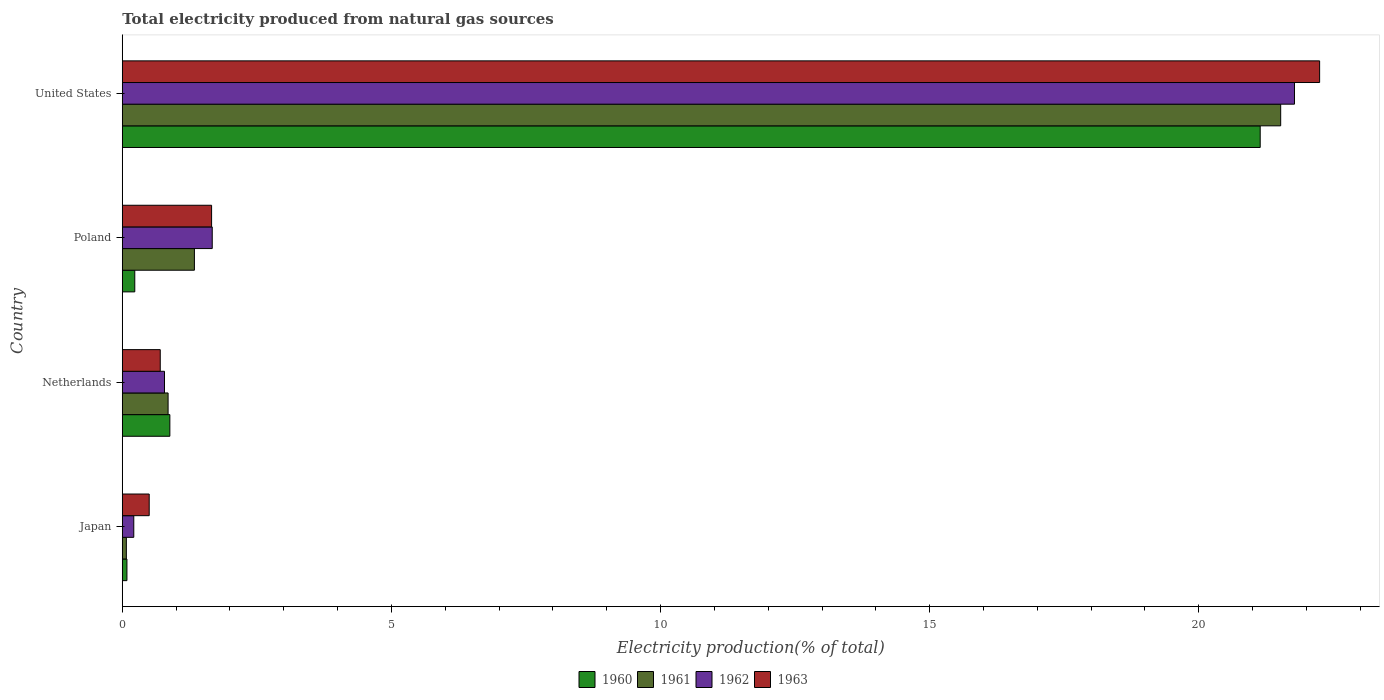How many groups of bars are there?
Offer a very short reply. 4. Are the number of bars on each tick of the Y-axis equal?
Offer a very short reply. Yes. How many bars are there on the 1st tick from the top?
Provide a short and direct response. 4. What is the total electricity produced in 1961 in Netherlands?
Provide a short and direct response. 0.85. Across all countries, what is the maximum total electricity produced in 1960?
Offer a terse response. 21.14. Across all countries, what is the minimum total electricity produced in 1960?
Offer a very short reply. 0.09. In which country was the total electricity produced in 1962 minimum?
Ensure brevity in your answer.  Japan. What is the total total electricity produced in 1962 in the graph?
Ensure brevity in your answer.  24.45. What is the difference between the total electricity produced in 1961 in Poland and that in United States?
Offer a terse response. -20.18. What is the difference between the total electricity produced in 1962 in Japan and the total electricity produced in 1960 in Poland?
Your response must be concise. -0.02. What is the average total electricity produced in 1962 per country?
Give a very brief answer. 6.11. What is the difference between the total electricity produced in 1961 and total electricity produced in 1962 in Poland?
Your answer should be very brief. -0.33. In how many countries, is the total electricity produced in 1963 greater than 9 %?
Give a very brief answer. 1. What is the ratio of the total electricity produced in 1961 in Poland to that in United States?
Offer a terse response. 0.06. Is the total electricity produced in 1960 in Netherlands less than that in Poland?
Keep it short and to the point. No. What is the difference between the highest and the second highest total electricity produced in 1962?
Make the answer very short. 20.11. What is the difference between the highest and the lowest total electricity produced in 1962?
Your answer should be very brief. 21.56. In how many countries, is the total electricity produced in 1962 greater than the average total electricity produced in 1962 taken over all countries?
Your answer should be very brief. 1. Is it the case that in every country, the sum of the total electricity produced in 1962 and total electricity produced in 1963 is greater than the sum of total electricity produced in 1960 and total electricity produced in 1961?
Provide a short and direct response. No. What does the 3rd bar from the top in Netherlands represents?
Your response must be concise. 1961. What is the difference between two consecutive major ticks on the X-axis?
Ensure brevity in your answer.  5. Are the values on the major ticks of X-axis written in scientific E-notation?
Provide a short and direct response. No. Where does the legend appear in the graph?
Give a very brief answer. Bottom center. What is the title of the graph?
Your answer should be compact. Total electricity produced from natural gas sources. What is the label or title of the Y-axis?
Your answer should be compact. Country. What is the Electricity production(% of total) in 1960 in Japan?
Ensure brevity in your answer.  0.09. What is the Electricity production(% of total) in 1961 in Japan?
Ensure brevity in your answer.  0.08. What is the Electricity production(% of total) in 1962 in Japan?
Your answer should be compact. 0.21. What is the Electricity production(% of total) of 1963 in Japan?
Give a very brief answer. 0.5. What is the Electricity production(% of total) of 1960 in Netherlands?
Ensure brevity in your answer.  0.88. What is the Electricity production(% of total) of 1961 in Netherlands?
Make the answer very short. 0.85. What is the Electricity production(% of total) of 1962 in Netherlands?
Ensure brevity in your answer.  0.78. What is the Electricity production(% of total) in 1963 in Netherlands?
Keep it short and to the point. 0.71. What is the Electricity production(% of total) of 1960 in Poland?
Offer a very short reply. 0.23. What is the Electricity production(% of total) in 1961 in Poland?
Give a very brief answer. 1.34. What is the Electricity production(% of total) of 1962 in Poland?
Offer a very short reply. 1.67. What is the Electricity production(% of total) in 1963 in Poland?
Provide a succinct answer. 1.66. What is the Electricity production(% of total) in 1960 in United States?
Keep it short and to the point. 21.14. What is the Electricity production(% of total) of 1961 in United States?
Offer a terse response. 21.52. What is the Electricity production(% of total) in 1962 in United States?
Ensure brevity in your answer.  21.78. What is the Electricity production(% of total) of 1963 in United States?
Offer a terse response. 22.24. Across all countries, what is the maximum Electricity production(% of total) in 1960?
Offer a terse response. 21.14. Across all countries, what is the maximum Electricity production(% of total) in 1961?
Your response must be concise. 21.52. Across all countries, what is the maximum Electricity production(% of total) of 1962?
Ensure brevity in your answer.  21.78. Across all countries, what is the maximum Electricity production(% of total) of 1963?
Provide a short and direct response. 22.24. Across all countries, what is the minimum Electricity production(% of total) in 1960?
Offer a very short reply. 0.09. Across all countries, what is the minimum Electricity production(% of total) of 1961?
Provide a short and direct response. 0.08. Across all countries, what is the minimum Electricity production(% of total) in 1962?
Your answer should be very brief. 0.21. Across all countries, what is the minimum Electricity production(% of total) in 1963?
Provide a succinct answer. 0.5. What is the total Electricity production(% of total) in 1960 in the graph?
Provide a succinct answer. 22.34. What is the total Electricity production(% of total) of 1961 in the graph?
Keep it short and to the point. 23.79. What is the total Electricity production(% of total) in 1962 in the graph?
Your answer should be very brief. 24.45. What is the total Electricity production(% of total) in 1963 in the graph?
Offer a terse response. 25.11. What is the difference between the Electricity production(% of total) of 1960 in Japan and that in Netherlands?
Provide a succinct answer. -0.8. What is the difference between the Electricity production(% of total) of 1961 in Japan and that in Netherlands?
Offer a very short reply. -0.78. What is the difference between the Electricity production(% of total) of 1962 in Japan and that in Netherlands?
Provide a short and direct response. -0.57. What is the difference between the Electricity production(% of total) in 1963 in Japan and that in Netherlands?
Offer a terse response. -0.21. What is the difference between the Electricity production(% of total) of 1960 in Japan and that in Poland?
Your answer should be compact. -0.15. What is the difference between the Electricity production(% of total) of 1961 in Japan and that in Poland?
Provide a succinct answer. -1.26. What is the difference between the Electricity production(% of total) in 1962 in Japan and that in Poland?
Your response must be concise. -1.46. What is the difference between the Electricity production(% of total) in 1963 in Japan and that in Poland?
Make the answer very short. -1.16. What is the difference between the Electricity production(% of total) of 1960 in Japan and that in United States?
Your response must be concise. -21.05. What is the difference between the Electricity production(% of total) in 1961 in Japan and that in United States?
Offer a terse response. -21.45. What is the difference between the Electricity production(% of total) in 1962 in Japan and that in United States?
Ensure brevity in your answer.  -21.56. What is the difference between the Electricity production(% of total) of 1963 in Japan and that in United States?
Your response must be concise. -21.74. What is the difference between the Electricity production(% of total) in 1960 in Netherlands and that in Poland?
Keep it short and to the point. 0.65. What is the difference between the Electricity production(% of total) in 1961 in Netherlands and that in Poland?
Give a very brief answer. -0.49. What is the difference between the Electricity production(% of total) of 1962 in Netherlands and that in Poland?
Offer a very short reply. -0.89. What is the difference between the Electricity production(% of total) of 1963 in Netherlands and that in Poland?
Offer a terse response. -0.95. What is the difference between the Electricity production(% of total) in 1960 in Netherlands and that in United States?
Your response must be concise. -20.26. What is the difference between the Electricity production(% of total) in 1961 in Netherlands and that in United States?
Your answer should be compact. -20.67. What is the difference between the Electricity production(% of total) of 1962 in Netherlands and that in United States?
Ensure brevity in your answer.  -20.99. What is the difference between the Electricity production(% of total) in 1963 in Netherlands and that in United States?
Provide a succinct answer. -21.54. What is the difference between the Electricity production(% of total) in 1960 in Poland and that in United States?
Offer a terse response. -20.91. What is the difference between the Electricity production(% of total) in 1961 in Poland and that in United States?
Provide a short and direct response. -20.18. What is the difference between the Electricity production(% of total) in 1962 in Poland and that in United States?
Your answer should be compact. -20.11. What is the difference between the Electricity production(% of total) of 1963 in Poland and that in United States?
Make the answer very short. -20.59. What is the difference between the Electricity production(% of total) of 1960 in Japan and the Electricity production(% of total) of 1961 in Netherlands?
Keep it short and to the point. -0.76. What is the difference between the Electricity production(% of total) of 1960 in Japan and the Electricity production(% of total) of 1962 in Netherlands?
Your answer should be very brief. -0.7. What is the difference between the Electricity production(% of total) of 1960 in Japan and the Electricity production(% of total) of 1963 in Netherlands?
Provide a short and direct response. -0.62. What is the difference between the Electricity production(% of total) of 1961 in Japan and the Electricity production(% of total) of 1962 in Netherlands?
Provide a succinct answer. -0.71. What is the difference between the Electricity production(% of total) in 1961 in Japan and the Electricity production(% of total) in 1963 in Netherlands?
Offer a terse response. -0.63. What is the difference between the Electricity production(% of total) in 1962 in Japan and the Electricity production(% of total) in 1963 in Netherlands?
Give a very brief answer. -0.49. What is the difference between the Electricity production(% of total) of 1960 in Japan and the Electricity production(% of total) of 1961 in Poland?
Provide a short and direct response. -1.25. What is the difference between the Electricity production(% of total) of 1960 in Japan and the Electricity production(% of total) of 1962 in Poland?
Ensure brevity in your answer.  -1.58. What is the difference between the Electricity production(% of total) of 1960 in Japan and the Electricity production(% of total) of 1963 in Poland?
Make the answer very short. -1.57. What is the difference between the Electricity production(% of total) of 1961 in Japan and the Electricity production(% of total) of 1962 in Poland?
Make the answer very short. -1.6. What is the difference between the Electricity production(% of total) of 1961 in Japan and the Electricity production(% of total) of 1963 in Poland?
Give a very brief answer. -1.58. What is the difference between the Electricity production(% of total) in 1962 in Japan and the Electricity production(% of total) in 1963 in Poland?
Give a very brief answer. -1.45. What is the difference between the Electricity production(% of total) in 1960 in Japan and the Electricity production(% of total) in 1961 in United States?
Make the answer very short. -21.43. What is the difference between the Electricity production(% of total) in 1960 in Japan and the Electricity production(% of total) in 1962 in United States?
Give a very brief answer. -21.69. What is the difference between the Electricity production(% of total) of 1960 in Japan and the Electricity production(% of total) of 1963 in United States?
Make the answer very short. -22.16. What is the difference between the Electricity production(% of total) of 1961 in Japan and the Electricity production(% of total) of 1962 in United States?
Provide a short and direct response. -21.7. What is the difference between the Electricity production(% of total) in 1961 in Japan and the Electricity production(% of total) in 1963 in United States?
Offer a very short reply. -22.17. What is the difference between the Electricity production(% of total) in 1962 in Japan and the Electricity production(% of total) in 1963 in United States?
Give a very brief answer. -22.03. What is the difference between the Electricity production(% of total) of 1960 in Netherlands and the Electricity production(% of total) of 1961 in Poland?
Provide a succinct answer. -0.46. What is the difference between the Electricity production(% of total) in 1960 in Netherlands and the Electricity production(% of total) in 1962 in Poland?
Provide a succinct answer. -0.79. What is the difference between the Electricity production(% of total) in 1960 in Netherlands and the Electricity production(% of total) in 1963 in Poland?
Provide a short and direct response. -0.78. What is the difference between the Electricity production(% of total) of 1961 in Netherlands and the Electricity production(% of total) of 1962 in Poland?
Make the answer very short. -0.82. What is the difference between the Electricity production(% of total) of 1961 in Netherlands and the Electricity production(% of total) of 1963 in Poland?
Your response must be concise. -0.81. What is the difference between the Electricity production(% of total) in 1962 in Netherlands and the Electricity production(% of total) in 1963 in Poland?
Provide a short and direct response. -0.88. What is the difference between the Electricity production(% of total) of 1960 in Netherlands and the Electricity production(% of total) of 1961 in United States?
Provide a succinct answer. -20.64. What is the difference between the Electricity production(% of total) in 1960 in Netherlands and the Electricity production(% of total) in 1962 in United States?
Keep it short and to the point. -20.89. What is the difference between the Electricity production(% of total) of 1960 in Netherlands and the Electricity production(% of total) of 1963 in United States?
Provide a short and direct response. -21.36. What is the difference between the Electricity production(% of total) in 1961 in Netherlands and the Electricity production(% of total) in 1962 in United States?
Your answer should be very brief. -20.93. What is the difference between the Electricity production(% of total) of 1961 in Netherlands and the Electricity production(% of total) of 1963 in United States?
Provide a succinct answer. -21.39. What is the difference between the Electricity production(% of total) of 1962 in Netherlands and the Electricity production(% of total) of 1963 in United States?
Keep it short and to the point. -21.46. What is the difference between the Electricity production(% of total) of 1960 in Poland and the Electricity production(% of total) of 1961 in United States?
Your answer should be very brief. -21.29. What is the difference between the Electricity production(% of total) in 1960 in Poland and the Electricity production(% of total) in 1962 in United States?
Offer a very short reply. -21.55. What is the difference between the Electricity production(% of total) in 1960 in Poland and the Electricity production(% of total) in 1963 in United States?
Your answer should be very brief. -22.01. What is the difference between the Electricity production(% of total) of 1961 in Poland and the Electricity production(% of total) of 1962 in United States?
Offer a very short reply. -20.44. What is the difference between the Electricity production(% of total) in 1961 in Poland and the Electricity production(% of total) in 1963 in United States?
Provide a succinct answer. -20.91. What is the difference between the Electricity production(% of total) of 1962 in Poland and the Electricity production(% of total) of 1963 in United States?
Offer a terse response. -20.57. What is the average Electricity production(% of total) in 1960 per country?
Your response must be concise. 5.59. What is the average Electricity production(% of total) in 1961 per country?
Your response must be concise. 5.95. What is the average Electricity production(% of total) of 1962 per country?
Provide a short and direct response. 6.11. What is the average Electricity production(% of total) in 1963 per country?
Ensure brevity in your answer.  6.28. What is the difference between the Electricity production(% of total) in 1960 and Electricity production(% of total) in 1961 in Japan?
Ensure brevity in your answer.  0.01. What is the difference between the Electricity production(% of total) of 1960 and Electricity production(% of total) of 1962 in Japan?
Your response must be concise. -0.13. What is the difference between the Electricity production(% of total) in 1960 and Electricity production(% of total) in 1963 in Japan?
Make the answer very short. -0.41. What is the difference between the Electricity production(% of total) of 1961 and Electricity production(% of total) of 1962 in Japan?
Keep it short and to the point. -0.14. What is the difference between the Electricity production(% of total) in 1961 and Electricity production(% of total) in 1963 in Japan?
Give a very brief answer. -0.42. What is the difference between the Electricity production(% of total) of 1962 and Electricity production(% of total) of 1963 in Japan?
Your response must be concise. -0.29. What is the difference between the Electricity production(% of total) of 1960 and Electricity production(% of total) of 1961 in Netherlands?
Give a very brief answer. 0.03. What is the difference between the Electricity production(% of total) of 1960 and Electricity production(% of total) of 1962 in Netherlands?
Your answer should be very brief. 0.1. What is the difference between the Electricity production(% of total) in 1960 and Electricity production(% of total) in 1963 in Netherlands?
Ensure brevity in your answer.  0.18. What is the difference between the Electricity production(% of total) in 1961 and Electricity production(% of total) in 1962 in Netherlands?
Provide a short and direct response. 0.07. What is the difference between the Electricity production(% of total) in 1961 and Electricity production(% of total) in 1963 in Netherlands?
Your answer should be compact. 0.15. What is the difference between the Electricity production(% of total) of 1962 and Electricity production(% of total) of 1963 in Netherlands?
Make the answer very short. 0.08. What is the difference between the Electricity production(% of total) in 1960 and Electricity production(% of total) in 1961 in Poland?
Keep it short and to the point. -1.11. What is the difference between the Electricity production(% of total) of 1960 and Electricity production(% of total) of 1962 in Poland?
Your response must be concise. -1.44. What is the difference between the Electricity production(% of total) in 1960 and Electricity production(% of total) in 1963 in Poland?
Ensure brevity in your answer.  -1.43. What is the difference between the Electricity production(% of total) in 1961 and Electricity production(% of total) in 1962 in Poland?
Keep it short and to the point. -0.33. What is the difference between the Electricity production(% of total) in 1961 and Electricity production(% of total) in 1963 in Poland?
Keep it short and to the point. -0.32. What is the difference between the Electricity production(% of total) of 1962 and Electricity production(% of total) of 1963 in Poland?
Give a very brief answer. 0.01. What is the difference between the Electricity production(% of total) of 1960 and Electricity production(% of total) of 1961 in United States?
Keep it short and to the point. -0.38. What is the difference between the Electricity production(% of total) of 1960 and Electricity production(% of total) of 1962 in United States?
Your response must be concise. -0.64. What is the difference between the Electricity production(% of total) of 1960 and Electricity production(% of total) of 1963 in United States?
Provide a succinct answer. -1.1. What is the difference between the Electricity production(% of total) of 1961 and Electricity production(% of total) of 1962 in United States?
Your response must be concise. -0.26. What is the difference between the Electricity production(% of total) of 1961 and Electricity production(% of total) of 1963 in United States?
Give a very brief answer. -0.72. What is the difference between the Electricity production(% of total) of 1962 and Electricity production(% of total) of 1963 in United States?
Provide a short and direct response. -0.47. What is the ratio of the Electricity production(% of total) of 1960 in Japan to that in Netherlands?
Your response must be concise. 0.1. What is the ratio of the Electricity production(% of total) in 1961 in Japan to that in Netherlands?
Your response must be concise. 0.09. What is the ratio of the Electricity production(% of total) of 1962 in Japan to that in Netherlands?
Your answer should be very brief. 0.27. What is the ratio of the Electricity production(% of total) in 1963 in Japan to that in Netherlands?
Keep it short and to the point. 0.71. What is the ratio of the Electricity production(% of total) in 1960 in Japan to that in Poland?
Give a very brief answer. 0.37. What is the ratio of the Electricity production(% of total) of 1961 in Japan to that in Poland?
Keep it short and to the point. 0.06. What is the ratio of the Electricity production(% of total) in 1962 in Japan to that in Poland?
Your answer should be compact. 0.13. What is the ratio of the Electricity production(% of total) of 1963 in Japan to that in Poland?
Offer a very short reply. 0.3. What is the ratio of the Electricity production(% of total) of 1960 in Japan to that in United States?
Give a very brief answer. 0. What is the ratio of the Electricity production(% of total) of 1961 in Japan to that in United States?
Provide a succinct answer. 0. What is the ratio of the Electricity production(% of total) of 1962 in Japan to that in United States?
Offer a terse response. 0.01. What is the ratio of the Electricity production(% of total) in 1963 in Japan to that in United States?
Give a very brief answer. 0.02. What is the ratio of the Electricity production(% of total) of 1960 in Netherlands to that in Poland?
Provide a short and direct response. 3.81. What is the ratio of the Electricity production(% of total) in 1961 in Netherlands to that in Poland?
Provide a short and direct response. 0.64. What is the ratio of the Electricity production(% of total) of 1962 in Netherlands to that in Poland?
Ensure brevity in your answer.  0.47. What is the ratio of the Electricity production(% of total) of 1963 in Netherlands to that in Poland?
Keep it short and to the point. 0.42. What is the ratio of the Electricity production(% of total) of 1960 in Netherlands to that in United States?
Offer a very short reply. 0.04. What is the ratio of the Electricity production(% of total) of 1961 in Netherlands to that in United States?
Offer a terse response. 0.04. What is the ratio of the Electricity production(% of total) of 1962 in Netherlands to that in United States?
Give a very brief answer. 0.04. What is the ratio of the Electricity production(% of total) in 1963 in Netherlands to that in United States?
Your answer should be compact. 0.03. What is the ratio of the Electricity production(% of total) in 1960 in Poland to that in United States?
Give a very brief answer. 0.01. What is the ratio of the Electricity production(% of total) of 1961 in Poland to that in United States?
Provide a succinct answer. 0.06. What is the ratio of the Electricity production(% of total) of 1962 in Poland to that in United States?
Your response must be concise. 0.08. What is the ratio of the Electricity production(% of total) in 1963 in Poland to that in United States?
Give a very brief answer. 0.07. What is the difference between the highest and the second highest Electricity production(% of total) of 1960?
Your answer should be compact. 20.26. What is the difference between the highest and the second highest Electricity production(% of total) in 1961?
Make the answer very short. 20.18. What is the difference between the highest and the second highest Electricity production(% of total) in 1962?
Give a very brief answer. 20.11. What is the difference between the highest and the second highest Electricity production(% of total) in 1963?
Your answer should be compact. 20.59. What is the difference between the highest and the lowest Electricity production(% of total) in 1960?
Give a very brief answer. 21.05. What is the difference between the highest and the lowest Electricity production(% of total) of 1961?
Provide a succinct answer. 21.45. What is the difference between the highest and the lowest Electricity production(% of total) in 1962?
Your answer should be very brief. 21.56. What is the difference between the highest and the lowest Electricity production(% of total) in 1963?
Ensure brevity in your answer.  21.74. 